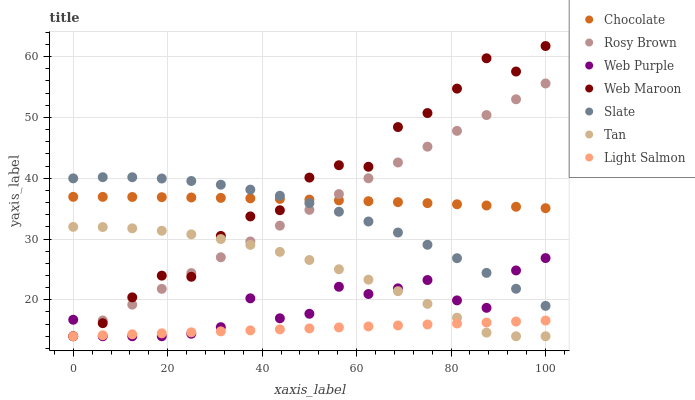Does Light Salmon have the minimum area under the curve?
Answer yes or no. Yes. Does Web Maroon have the maximum area under the curve?
Answer yes or no. Yes. Does Slate have the minimum area under the curve?
Answer yes or no. No. Does Slate have the maximum area under the curve?
Answer yes or no. No. Is Light Salmon the smoothest?
Answer yes or no. Yes. Is Web Maroon the roughest?
Answer yes or no. Yes. Is Slate the smoothest?
Answer yes or no. No. Is Slate the roughest?
Answer yes or no. No. Does Light Salmon have the lowest value?
Answer yes or no. Yes. Does Slate have the lowest value?
Answer yes or no. No. Does Web Maroon have the highest value?
Answer yes or no. Yes. Does Slate have the highest value?
Answer yes or no. No. Is Web Purple less than Chocolate?
Answer yes or no. Yes. Is Slate greater than Light Salmon?
Answer yes or no. Yes. Does Tan intersect Web Maroon?
Answer yes or no. Yes. Is Tan less than Web Maroon?
Answer yes or no. No. Is Tan greater than Web Maroon?
Answer yes or no. No. Does Web Purple intersect Chocolate?
Answer yes or no. No. 